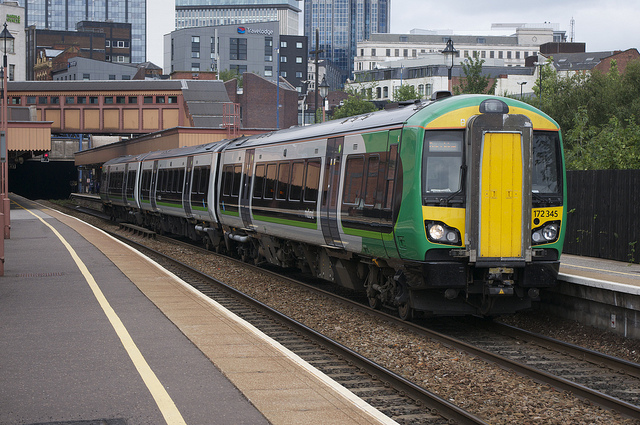<image>What country's flag does the colors of the train resemble? It is ambiguous what country's flag the colors of the train resemble. It may be similar to the flags of Brazil, Jamaica, Canada, or Ireland. What country's flag does the colors of the train resemble? I don't know what country's flag does the colors of the train resemble. It can be Brazil, Jamaica, Canada or Ireland. 